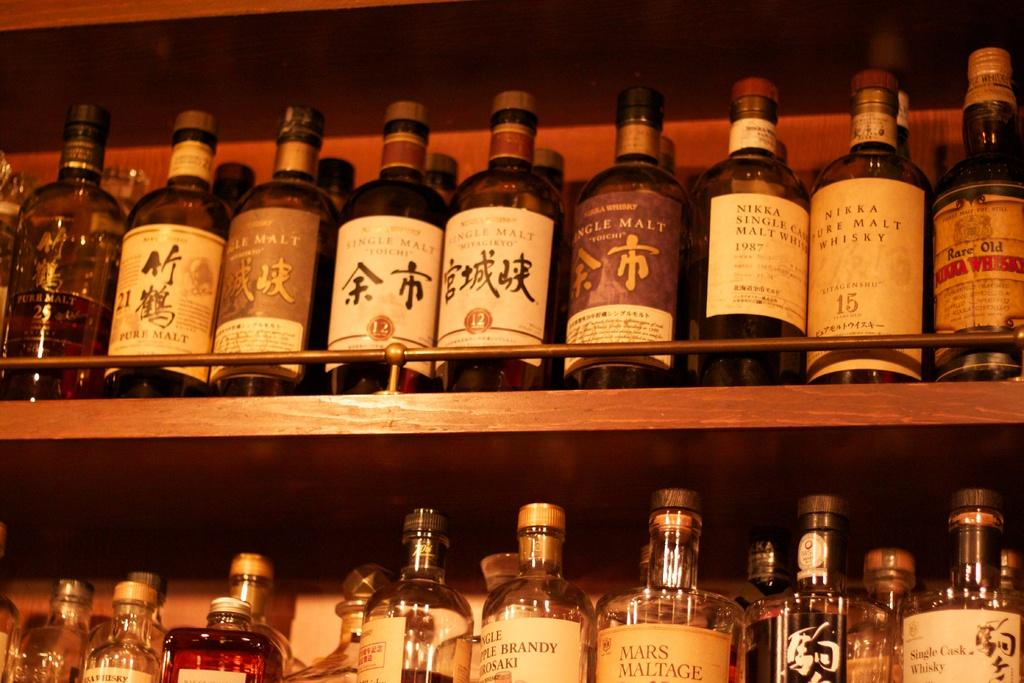<image>
Relay a brief, clear account of the picture shown. the word malt is on a purple bottle 